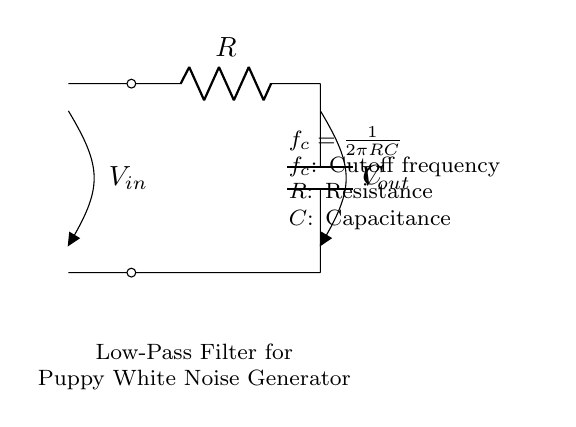What are the components used in this circuit? The components of the circuit are the resistor and the capacitor, which are indicated as R and C, respectively. The diagram clearly displays these components with their labels.
Answer: Resistor and capacitor What is the purpose of this circuit? The purpose of this circuit is to serve as a low-pass filter, which allows low-frequency signals, such as calming white noise for puppies, to pass through while attenuating higher frequencies. This is indicated by the circuits' name and configuration as a low-pass filter.
Answer: Calming white noise generator What is the cutoff frequency formula? The cutoff frequency formula can be found in the circuit's description, showing that it is \(f_c = \frac{1}{2\pi RC}\). This relationship defines how the cutoff frequency is calculated based on the resistance and capacitance values.
Answer: \(f_c = \frac{1}{2\pi RC}\) What is the significance of the cutoff frequency? The cutoff frequency is significant because it determines the threshold above which the filter attenuates signals. Frequencies below this value pass through the filter, which is essential for generating the desired calming sounds for puppies.
Answer: Determines the threshold for signal attenuation How does increasing resistance affect the cutoff frequency? Increasing the resistance will lower the cutoff frequency, since \(f_c\) is inversely proportional to \(R\) in the formula \(f_c = \frac{1}{2\pi RC}\). This means that a higher resistance allows lower frequencies to pass more easily, which is beneficial for producing calming sounds.
Answer: Lowers cutoff frequency What will happen if the capacitor value is decreased? Decreasing the capacitor value will increase the cutoff frequency, as \(f_c\) is directly proportional to \(\frac{1}{C}\). This results in allowing relatively higher frequencies to pass through the filter, which could interfere with the calming purpose intended for the circuit.
Answer: Increases cutoff frequency 